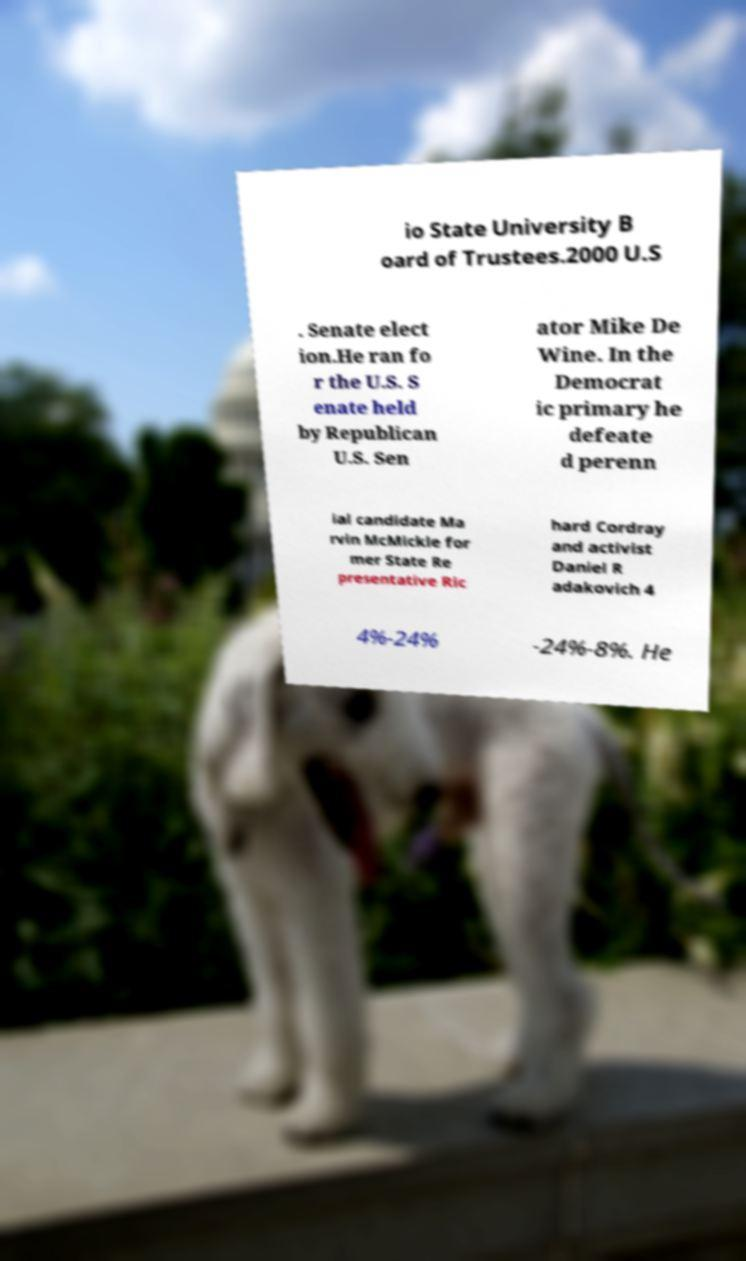Could you assist in decoding the text presented in this image and type it out clearly? io State University B oard of Trustees.2000 U.S . Senate elect ion.He ran fo r the U.S. S enate held by Republican U.S. Sen ator Mike De Wine. In the Democrat ic primary he defeate d perenn ial candidate Ma rvin McMickle for mer State Re presentative Ric hard Cordray and activist Daniel R adakovich 4 4%-24% -24%-8%. He 